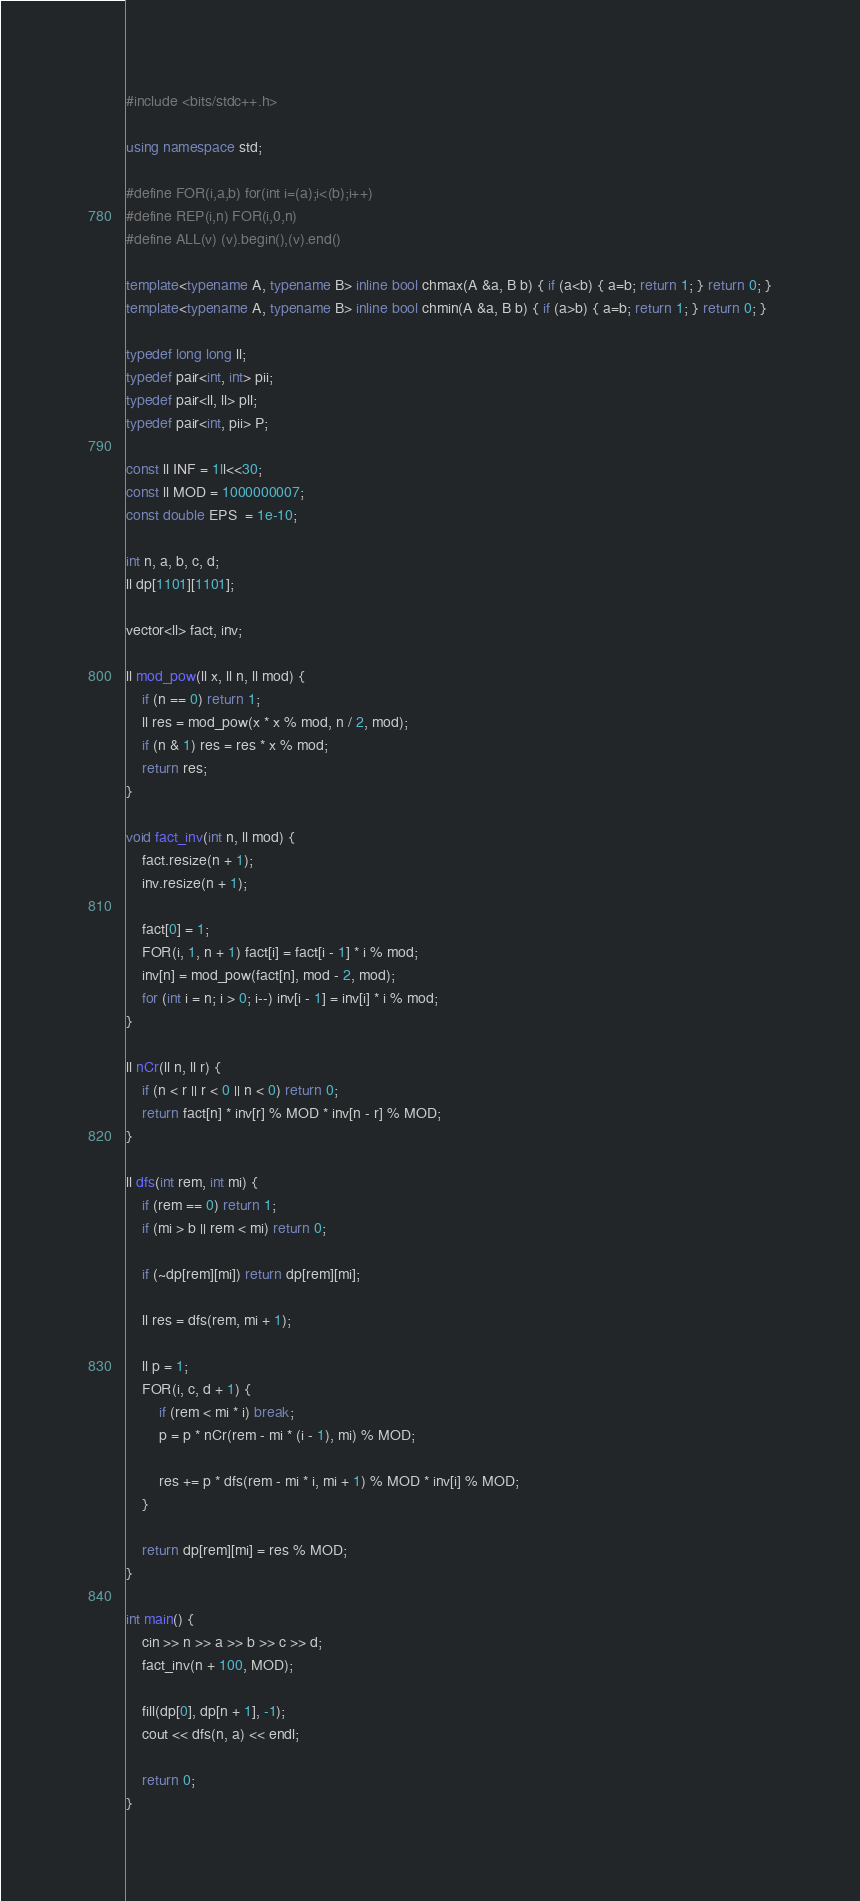<code> <loc_0><loc_0><loc_500><loc_500><_C++_>#include <bits/stdc++.h>

using namespace std;

#define FOR(i,a,b) for(int i=(a);i<(b);i++)
#define REP(i,n) FOR(i,0,n)
#define ALL(v) (v).begin(),(v).end()

template<typename A, typename B> inline bool chmax(A &a, B b) { if (a<b) { a=b; return 1; } return 0; }
template<typename A, typename B> inline bool chmin(A &a, B b) { if (a>b) { a=b; return 1; } return 0; }

typedef long long ll;
typedef pair<int, int> pii;
typedef pair<ll, ll> pll;
typedef pair<int, pii> P;

const ll INF = 1ll<<30;
const ll MOD = 1000000007;
const double EPS  = 1e-10;

int n, a, b, c, d;
ll dp[1101][1101];

vector<ll> fact, inv;

ll mod_pow(ll x, ll n, ll mod) {
	if (n == 0) return 1;
	ll res = mod_pow(x * x % mod, n / 2, mod);
	if (n & 1) res = res * x % mod;
	return res;
}

void fact_inv(int n, ll mod) {
	fact.resize(n + 1);
	inv.resize(n + 1);
	
	fact[0] = 1;
	FOR(i, 1, n + 1) fact[i] = fact[i - 1] * i % mod;
	inv[n] = mod_pow(fact[n], mod - 2, mod);
	for (int i = n; i > 0; i--) inv[i - 1] = inv[i] * i % mod;
}

ll nCr(ll n, ll r) {
	if (n < r || r < 0 || n < 0) return 0;
	return fact[n] * inv[r] % MOD * inv[n - r] % MOD;
}

ll dfs(int rem, int mi) {
	if (rem == 0) return 1;
	if (mi > b || rem < mi) return 0;
	
	if (~dp[rem][mi]) return dp[rem][mi];
	
	ll res = dfs(rem, mi + 1);
	
	ll p = 1;
	FOR(i, c, d + 1) {
		if (rem < mi * i) break;
		p = p * nCr(rem - mi * (i - 1), mi) % MOD;
		
		res += p * dfs(rem - mi * i, mi + 1) % MOD * inv[i] % MOD;
	}
		
	return dp[rem][mi] = res % MOD;
}

int main() {
	cin >> n >> a >> b >> c >> d;
	fact_inv(n + 100, MOD);
	
	fill(dp[0], dp[n + 1], -1);
	cout << dfs(n, a) << endl;
	
	return 0;
}</code> 